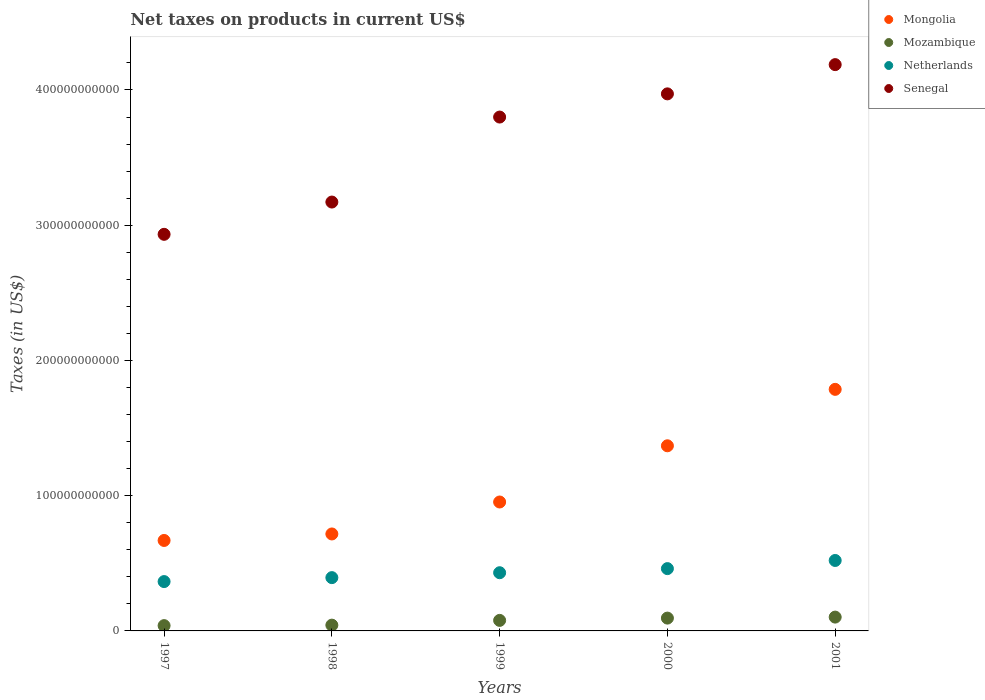Is the number of dotlines equal to the number of legend labels?
Your answer should be compact. Yes. What is the net taxes on products in Netherlands in 1997?
Offer a terse response. 3.65e+1. Across all years, what is the maximum net taxes on products in Mozambique?
Give a very brief answer. 1.02e+1. Across all years, what is the minimum net taxes on products in Senegal?
Your answer should be very brief. 2.93e+11. What is the total net taxes on products in Senegal in the graph?
Your answer should be very brief. 1.81e+12. What is the difference between the net taxes on products in Netherlands in 1998 and that in 2001?
Provide a succinct answer. -1.27e+1. What is the difference between the net taxes on products in Senegal in 2001 and the net taxes on products in Netherlands in 2000?
Offer a terse response. 3.73e+11. What is the average net taxes on products in Netherlands per year?
Make the answer very short. 4.34e+1. In the year 2000, what is the difference between the net taxes on products in Mongolia and net taxes on products in Mozambique?
Provide a short and direct response. 1.27e+11. In how many years, is the net taxes on products in Mozambique greater than 20000000000 US$?
Your response must be concise. 0. What is the ratio of the net taxes on products in Senegal in 2000 to that in 2001?
Keep it short and to the point. 0.95. Is the net taxes on products in Netherlands in 1999 less than that in 2000?
Your answer should be compact. Yes. What is the difference between the highest and the second highest net taxes on products in Mozambique?
Keep it short and to the point. 7.42e+08. What is the difference between the highest and the lowest net taxes on products in Netherlands?
Your answer should be compact. 1.56e+1. Is it the case that in every year, the sum of the net taxes on products in Netherlands and net taxes on products in Senegal  is greater than the sum of net taxes on products in Mozambique and net taxes on products in Mongolia?
Keep it short and to the point. Yes. Is it the case that in every year, the sum of the net taxes on products in Mongolia and net taxes on products in Mozambique  is greater than the net taxes on products in Netherlands?
Ensure brevity in your answer.  Yes. Is the net taxes on products in Senegal strictly greater than the net taxes on products in Netherlands over the years?
Provide a succinct answer. Yes. How many dotlines are there?
Your answer should be compact. 4. What is the difference between two consecutive major ticks on the Y-axis?
Your response must be concise. 1.00e+11. Are the values on the major ticks of Y-axis written in scientific E-notation?
Provide a short and direct response. No. Does the graph contain grids?
Provide a short and direct response. No. Where does the legend appear in the graph?
Keep it short and to the point. Top right. How many legend labels are there?
Ensure brevity in your answer.  4. How are the legend labels stacked?
Give a very brief answer. Vertical. What is the title of the graph?
Your answer should be very brief. Net taxes on products in current US$. Does "Northern Mariana Islands" appear as one of the legend labels in the graph?
Provide a succinct answer. No. What is the label or title of the X-axis?
Make the answer very short. Years. What is the label or title of the Y-axis?
Your answer should be compact. Taxes (in US$). What is the Taxes (in US$) in Mongolia in 1997?
Offer a very short reply. 6.69e+1. What is the Taxes (in US$) of Mozambique in 1997?
Your answer should be compact. 3.92e+09. What is the Taxes (in US$) of Netherlands in 1997?
Ensure brevity in your answer.  3.65e+1. What is the Taxes (in US$) in Senegal in 1997?
Make the answer very short. 2.93e+11. What is the Taxes (in US$) in Mongolia in 1998?
Your response must be concise. 7.17e+1. What is the Taxes (in US$) of Mozambique in 1998?
Your answer should be very brief. 4.27e+09. What is the Taxes (in US$) of Netherlands in 1998?
Your answer should be very brief. 3.94e+1. What is the Taxes (in US$) of Senegal in 1998?
Provide a short and direct response. 3.17e+11. What is the Taxes (in US$) of Mongolia in 1999?
Your response must be concise. 9.53e+1. What is the Taxes (in US$) in Mozambique in 1999?
Your answer should be very brief. 7.79e+09. What is the Taxes (in US$) of Netherlands in 1999?
Your answer should be compact. 4.30e+1. What is the Taxes (in US$) in Senegal in 1999?
Give a very brief answer. 3.80e+11. What is the Taxes (in US$) of Mongolia in 2000?
Make the answer very short. 1.37e+11. What is the Taxes (in US$) of Mozambique in 2000?
Your answer should be very brief. 9.48e+09. What is the Taxes (in US$) of Netherlands in 2000?
Make the answer very short. 4.61e+1. What is the Taxes (in US$) in Senegal in 2000?
Your answer should be compact. 3.97e+11. What is the Taxes (in US$) in Mongolia in 2001?
Your answer should be very brief. 1.79e+11. What is the Taxes (in US$) of Mozambique in 2001?
Keep it short and to the point. 1.02e+1. What is the Taxes (in US$) in Netherlands in 2001?
Your answer should be very brief. 5.21e+1. What is the Taxes (in US$) in Senegal in 2001?
Make the answer very short. 4.19e+11. Across all years, what is the maximum Taxes (in US$) of Mongolia?
Offer a terse response. 1.79e+11. Across all years, what is the maximum Taxes (in US$) of Mozambique?
Make the answer very short. 1.02e+1. Across all years, what is the maximum Taxes (in US$) in Netherlands?
Your response must be concise. 5.21e+1. Across all years, what is the maximum Taxes (in US$) of Senegal?
Make the answer very short. 4.19e+11. Across all years, what is the minimum Taxes (in US$) in Mongolia?
Make the answer very short. 6.69e+1. Across all years, what is the minimum Taxes (in US$) of Mozambique?
Provide a succinct answer. 3.92e+09. Across all years, what is the minimum Taxes (in US$) of Netherlands?
Ensure brevity in your answer.  3.65e+1. Across all years, what is the minimum Taxes (in US$) of Senegal?
Provide a succinct answer. 2.93e+11. What is the total Taxes (in US$) in Mongolia in the graph?
Ensure brevity in your answer.  5.49e+11. What is the total Taxes (in US$) of Mozambique in the graph?
Offer a very short reply. 3.57e+1. What is the total Taxes (in US$) of Netherlands in the graph?
Ensure brevity in your answer.  2.17e+11. What is the total Taxes (in US$) of Senegal in the graph?
Your response must be concise. 1.81e+12. What is the difference between the Taxes (in US$) in Mongolia in 1997 and that in 1998?
Provide a succinct answer. -4.81e+09. What is the difference between the Taxes (in US$) of Mozambique in 1997 and that in 1998?
Make the answer very short. -3.53e+08. What is the difference between the Taxes (in US$) of Netherlands in 1997 and that in 1998?
Give a very brief answer. -2.92e+09. What is the difference between the Taxes (in US$) in Senegal in 1997 and that in 1998?
Your answer should be compact. -2.39e+1. What is the difference between the Taxes (in US$) of Mongolia in 1997 and that in 1999?
Provide a succinct answer. -2.84e+1. What is the difference between the Taxes (in US$) of Mozambique in 1997 and that in 1999?
Offer a terse response. -3.87e+09. What is the difference between the Taxes (in US$) in Netherlands in 1997 and that in 1999?
Your answer should be compact. -6.55e+09. What is the difference between the Taxes (in US$) in Senegal in 1997 and that in 1999?
Your answer should be very brief. -8.67e+1. What is the difference between the Taxes (in US$) in Mongolia in 1997 and that in 2000?
Your answer should be very brief. -7.00e+1. What is the difference between the Taxes (in US$) in Mozambique in 1997 and that in 2000?
Offer a terse response. -5.56e+09. What is the difference between the Taxes (in US$) in Netherlands in 1997 and that in 2000?
Make the answer very short. -9.58e+09. What is the difference between the Taxes (in US$) in Senegal in 1997 and that in 2000?
Your answer should be compact. -1.04e+11. What is the difference between the Taxes (in US$) in Mongolia in 1997 and that in 2001?
Give a very brief answer. -1.12e+11. What is the difference between the Taxes (in US$) of Mozambique in 1997 and that in 2001?
Ensure brevity in your answer.  -6.30e+09. What is the difference between the Taxes (in US$) in Netherlands in 1997 and that in 2001?
Ensure brevity in your answer.  -1.56e+1. What is the difference between the Taxes (in US$) of Senegal in 1997 and that in 2001?
Your answer should be compact. -1.25e+11. What is the difference between the Taxes (in US$) in Mongolia in 1998 and that in 1999?
Give a very brief answer. -2.36e+1. What is the difference between the Taxes (in US$) of Mozambique in 1998 and that in 1999?
Your answer should be compact. -3.52e+09. What is the difference between the Taxes (in US$) of Netherlands in 1998 and that in 1999?
Give a very brief answer. -3.63e+09. What is the difference between the Taxes (in US$) of Senegal in 1998 and that in 1999?
Offer a terse response. -6.28e+1. What is the difference between the Taxes (in US$) of Mongolia in 1998 and that in 2000?
Provide a short and direct response. -6.52e+1. What is the difference between the Taxes (in US$) of Mozambique in 1998 and that in 2000?
Give a very brief answer. -5.21e+09. What is the difference between the Taxes (in US$) in Netherlands in 1998 and that in 2000?
Keep it short and to the point. -6.66e+09. What is the difference between the Taxes (in US$) in Senegal in 1998 and that in 2000?
Offer a terse response. -8.00e+1. What is the difference between the Taxes (in US$) in Mongolia in 1998 and that in 2001?
Provide a succinct answer. -1.07e+11. What is the difference between the Taxes (in US$) of Mozambique in 1998 and that in 2001?
Ensure brevity in your answer.  -5.95e+09. What is the difference between the Taxes (in US$) of Netherlands in 1998 and that in 2001?
Offer a very short reply. -1.27e+1. What is the difference between the Taxes (in US$) of Senegal in 1998 and that in 2001?
Your response must be concise. -1.02e+11. What is the difference between the Taxes (in US$) in Mongolia in 1999 and that in 2000?
Give a very brief answer. -4.16e+1. What is the difference between the Taxes (in US$) of Mozambique in 1999 and that in 2000?
Your answer should be very brief. -1.69e+09. What is the difference between the Taxes (in US$) of Netherlands in 1999 and that in 2000?
Your answer should be very brief. -3.04e+09. What is the difference between the Taxes (in US$) in Senegal in 1999 and that in 2000?
Your response must be concise. -1.72e+1. What is the difference between the Taxes (in US$) of Mongolia in 1999 and that in 2001?
Offer a very short reply. -8.33e+1. What is the difference between the Taxes (in US$) of Mozambique in 1999 and that in 2001?
Make the answer very short. -2.43e+09. What is the difference between the Taxes (in US$) of Netherlands in 1999 and that in 2001?
Offer a very short reply. -9.06e+09. What is the difference between the Taxes (in US$) in Senegal in 1999 and that in 2001?
Keep it short and to the point. -3.88e+1. What is the difference between the Taxes (in US$) in Mongolia in 2000 and that in 2001?
Keep it short and to the point. -4.17e+1. What is the difference between the Taxes (in US$) of Mozambique in 2000 and that in 2001?
Give a very brief answer. -7.42e+08. What is the difference between the Taxes (in US$) of Netherlands in 2000 and that in 2001?
Provide a short and direct response. -6.02e+09. What is the difference between the Taxes (in US$) in Senegal in 2000 and that in 2001?
Your answer should be compact. -2.16e+1. What is the difference between the Taxes (in US$) of Mongolia in 1997 and the Taxes (in US$) of Mozambique in 1998?
Your answer should be very brief. 6.26e+1. What is the difference between the Taxes (in US$) of Mongolia in 1997 and the Taxes (in US$) of Netherlands in 1998?
Your response must be concise. 2.75e+1. What is the difference between the Taxes (in US$) of Mongolia in 1997 and the Taxes (in US$) of Senegal in 1998?
Offer a terse response. -2.50e+11. What is the difference between the Taxes (in US$) of Mozambique in 1997 and the Taxes (in US$) of Netherlands in 1998?
Provide a short and direct response. -3.55e+1. What is the difference between the Taxes (in US$) in Mozambique in 1997 and the Taxes (in US$) in Senegal in 1998?
Give a very brief answer. -3.13e+11. What is the difference between the Taxes (in US$) of Netherlands in 1997 and the Taxes (in US$) of Senegal in 1998?
Your answer should be compact. -2.81e+11. What is the difference between the Taxes (in US$) in Mongolia in 1997 and the Taxes (in US$) in Mozambique in 1999?
Offer a very short reply. 5.91e+1. What is the difference between the Taxes (in US$) of Mongolia in 1997 and the Taxes (in US$) of Netherlands in 1999?
Your answer should be compact. 2.39e+1. What is the difference between the Taxes (in US$) of Mongolia in 1997 and the Taxes (in US$) of Senegal in 1999?
Make the answer very short. -3.13e+11. What is the difference between the Taxes (in US$) in Mozambique in 1997 and the Taxes (in US$) in Netherlands in 1999?
Provide a short and direct response. -3.91e+1. What is the difference between the Taxes (in US$) in Mozambique in 1997 and the Taxes (in US$) in Senegal in 1999?
Provide a short and direct response. -3.76e+11. What is the difference between the Taxes (in US$) in Netherlands in 1997 and the Taxes (in US$) in Senegal in 1999?
Ensure brevity in your answer.  -3.43e+11. What is the difference between the Taxes (in US$) in Mongolia in 1997 and the Taxes (in US$) in Mozambique in 2000?
Make the answer very short. 5.74e+1. What is the difference between the Taxes (in US$) in Mongolia in 1997 and the Taxes (in US$) in Netherlands in 2000?
Give a very brief answer. 2.08e+1. What is the difference between the Taxes (in US$) in Mongolia in 1997 and the Taxes (in US$) in Senegal in 2000?
Ensure brevity in your answer.  -3.30e+11. What is the difference between the Taxes (in US$) of Mozambique in 1997 and the Taxes (in US$) of Netherlands in 2000?
Your answer should be very brief. -4.22e+1. What is the difference between the Taxes (in US$) of Mozambique in 1997 and the Taxes (in US$) of Senegal in 2000?
Give a very brief answer. -3.93e+11. What is the difference between the Taxes (in US$) in Netherlands in 1997 and the Taxes (in US$) in Senegal in 2000?
Provide a short and direct response. -3.61e+11. What is the difference between the Taxes (in US$) of Mongolia in 1997 and the Taxes (in US$) of Mozambique in 2001?
Make the answer very short. 5.67e+1. What is the difference between the Taxes (in US$) in Mongolia in 1997 and the Taxes (in US$) in Netherlands in 2001?
Offer a very short reply. 1.48e+1. What is the difference between the Taxes (in US$) in Mongolia in 1997 and the Taxes (in US$) in Senegal in 2001?
Offer a very short reply. -3.52e+11. What is the difference between the Taxes (in US$) of Mozambique in 1997 and the Taxes (in US$) of Netherlands in 2001?
Ensure brevity in your answer.  -4.82e+1. What is the difference between the Taxes (in US$) of Mozambique in 1997 and the Taxes (in US$) of Senegal in 2001?
Keep it short and to the point. -4.15e+11. What is the difference between the Taxes (in US$) of Netherlands in 1997 and the Taxes (in US$) of Senegal in 2001?
Provide a succinct answer. -3.82e+11. What is the difference between the Taxes (in US$) of Mongolia in 1998 and the Taxes (in US$) of Mozambique in 1999?
Make the answer very short. 6.39e+1. What is the difference between the Taxes (in US$) of Mongolia in 1998 and the Taxes (in US$) of Netherlands in 1999?
Offer a terse response. 2.87e+1. What is the difference between the Taxes (in US$) in Mongolia in 1998 and the Taxes (in US$) in Senegal in 1999?
Ensure brevity in your answer.  -3.08e+11. What is the difference between the Taxes (in US$) in Mozambique in 1998 and the Taxes (in US$) in Netherlands in 1999?
Provide a succinct answer. -3.88e+1. What is the difference between the Taxes (in US$) in Mozambique in 1998 and the Taxes (in US$) in Senegal in 1999?
Give a very brief answer. -3.76e+11. What is the difference between the Taxes (in US$) in Netherlands in 1998 and the Taxes (in US$) in Senegal in 1999?
Offer a very short reply. -3.41e+11. What is the difference between the Taxes (in US$) of Mongolia in 1998 and the Taxes (in US$) of Mozambique in 2000?
Give a very brief answer. 6.22e+1. What is the difference between the Taxes (in US$) of Mongolia in 1998 and the Taxes (in US$) of Netherlands in 2000?
Provide a short and direct response. 2.56e+1. What is the difference between the Taxes (in US$) in Mongolia in 1998 and the Taxes (in US$) in Senegal in 2000?
Your response must be concise. -3.25e+11. What is the difference between the Taxes (in US$) in Mozambique in 1998 and the Taxes (in US$) in Netherlands in 2000?
Your answer should be compact. -4.18e+1. What is the difference between the Taxes (in US$) of Mozambique in 1998 and the Taxes (in US$) of Senegal in 2000?
Give a very brief answer. -3.93e+11. What is the difference between the Taxes (in US$) of Netherlands in 1998 and the Taxes (in US$) of Senegal in 2000?
Give a very brief answer. -3.58e+11. What is the difference between the Taxes (in US$) in Mongolia in 1998 and the Taxes (in US$) in Mozambique in 2001?
Make the answer very short. 6.15e+1. What is the difference between the Taxes (in US$) of Mongolia in 1998 and the Taxes (in US$) of Netherlands in 2001?
Make the answer very short. 1.96e+1. What is the difference between the Taxes (in US$) of Mongolia in 1998 and the Taxes (in US$) of Senegal in 2001?
Offer a terse response. -3.47e+11. What is the difference between the Taxes (in US$) in Mozambique in 1998 and the Taxes (in US$) in Netherlands in 2001?
Offer a terse response. -4.78e+1. What is the difference between the Taxes (in US$) in Mozambique in 1998 and the Taxes (in US$) in Senegal in 2001?
Offer a very short reply. -4.14e+11. What is the difference between the Taxes (in US$) in Netherlands in 1998 and the Taxes (in US$) in Senegal in 2001?
Your response must be concise. -3.79e+11. What is the difference between the Taxes (in US$) of Mongolia in 1999 and the Taxes (in US$) of Mozambique in 2000?
Make the answer very short. 8.59e+1. What is the difference between the Taxes (in US$) of Mongolia in 1999 and the Taxes (in US$) of Netherlands in 2000?
Offer a terse response. 4.93e+1. What is the difference between the Taxes (in US$) of Mongolia in 1999 and the Taxes (in US$) of Senegal in 2000?
Provide a succinct answer. -3.02e+11. What is the difference between the Taxes (in US$) in Mozambique in 1999 and the Taxes (in US$) in Netherlands in 2000?
Make the answer very short. -3.83e+1. What is the difference between the Taxes (in US$) in Mozambique in 1999 and the Taxes (in US$) in Senegal in 2000?
Offer a terse response. -3.89e+11. What is the difference between the Taxes (in US$) in Netherlands in 1999 and the Taxes (in US$) in Senegal in 2000?
Offer a terse response. -3.54e+11. What is the difference between the Taxes (in US$) of Mongolia in 1999 and the Taxes (in US$) of Mozambique in 2001?
Ensure brevity in your answer.  8.51e+1. What is the difference between the Taxes (in US$) in Mongolia in 1999 and the Taxes (in US$) in Netherlands in 2001?
Keep it short and to the point. 4.32e+1. What is the difference between the Taxes (in US$) of Mongolia in 1999 and the Taxes (in US$) of Senegal in 2001?
Keep it short and to the point. -3.23e+11. What is the difference between the Taxes (in US$) of Mozambique in 1999 and the Taxes (in US$) of Netherlands in 2001?
Give a very brief answer. -4.43e+1. What is the difference between the Taxes (in US$) of Mozambique in 1999 and the Taxes (in US$) of Senegal in 2001?
Offer a very short reply. -4.11e+11. What is the difference between the Taxes (in US$) in Netherlands in 1999 and the Taxes (in US$) in Senegal in 2001?
Offer a very short reply. -3.76e+11. What is the difference between the Taxes (in US$) in Mongolia in 2000 and the Taxes (in US$) in Mozambique in 2001?
Offer a very short reply. 1.27e+11. What is the difference between the Taxes (in US$) of Mongolia in 2000 and the Taxes (in US$) of Netherlands in 2001?
Your answer should be compact. 8.48e+1. What is the difference between the Taxes (in US$) in Mongolia in 2000 and the Taxes (in US$) in Senegal in 2001?
Offer a terse response. -2.82e+11. What is the difference between the Taxes (in US$) in Mozambique in 2000 and the Taxes (in US$) in Netherlands in 2001?
Provide a succinct answer. -4.26e+1. What is the difference between the Taxes (in US$) of Mozambique in 2000 and the Taxes (in US$) of Senegal in 2001?
Your response must be concise. -4.09e+11. What is the difference between the Taxes (in US$) in Netherlands in 2000 and the Taxes (in US$) in Senegal in 2001?
Provide a succinct answer. -3.73e+11. What is the average Taxes (in US$) in Mongolia per year?
Give a very brief answer. 1.10e+11. What is the average Taxes (in US$) in Mozambique per year?
Offer a very short reply. 7.13e+09. What is the average Taxes (in US$) in Netherlands per year?
Your answer should be compact. 4.34e+1. What is the average Taxes (in US$) in Senegal per year?
Offer a terse response. 3.61e+11. In the year 1997, what is the difference between the Taxes (in US$) in Mongolia and Taxes (in US$) in Mozambique?
Your response must be concise. 6.30e+1. In the year 1997, what is the difference between the Taxes (in US$) of Mongolia and Taxes (in US$) of Netherlands?
Provide a short and direct response. 3.04e+1. In the year 1997, what is the difference between the Taxes (in US$) in Mongolia and Taxes (in US$) in Senegal?
Ensure brevity in your answer.  -2.26e+11. In the year 1997, what is the difference between the Taxes (in US$) in Mozambique and Taxes (in US$) in Netherlands?
Keep it short and to the point. -3.26e+1. In the year 1997, what is the difference between the Taxes (in US$) of Mozambique and Taxes (in US$) of Senegal?
Your response must be concise. -2.89e+11. In the year 1997, what is the difference between the Taxes (in US$) of Netherlands and Taxes (in US$) of Senegal?
Your answer should be very brief. -2.57e+11. In the year 1998, what is the difference between the Taxes (in US$) in Mongolia and Taxes (in US$) in Mozambique?
Provide a succinct answer. 6.74e+1. In the year 1998, what is the difference between the Taxes (in US$) in Mongolia and Taxes (in US$) in Netherlands?
Your answer should be very brief. 3.23e+1. In the year 1998, what is the difference between the Taxes (in US$) of Mongolia and Taxes (in US$) of Senegal?
Your response must be concise. -2.45e+11. In the year 1998, what is the difference between the Taxes (in US$) of Mozambique and Taxes (in US$) of Netherlands?
Keep it short and to the point. -3.51e+1. In the year 1998, what is the difference between the Taxes (in US$) in Mozambique and Taxes (in US$) in Senegal?
Give a very brief answer. -3.13e+11. In the year 1998, what is the difference between the Taxes (in US$) in Netherlands and Taxes (in US$) in Senegal?
Your response must be concise. -2.78e+11. In the year 1999, what is the difference between the Taxes (in US$) in Mongolia and Taxes (in US$) in Mozambique?
Provide a short and direct response. 8.75e+1. In the year 1999, what is the difference between the Taxes (in US$) of Mongolia and Taxes (in US$) of Netherlands?
Keep it short and to the point. 5.23e+1. In the year 1999, what is the difference between the Taxes (in US$) in Mongolia and Taxes (in US$) in Senegal?
Give a very brief answer. -2.85e+11. In the year 1999, what is the difference between the Taxes (in US$) of Mozambique and Taxes (in US$) of Netherlands?
Ensure brevity in your answer.  -3.52e+1. In the year 1999, what is the difference between the Taxes (in US$) in Mozambique and Taxes (in US$) in Senegal?
Offer a very short reply. -3.72e+11. In the year 1999, what is the difference between the Taxes (in US$) in Netherlands and Taxes (in US$) in Senegal?
Provide a succinct answer. -3.37e+11. In the year 2000, what is the difference between the Taxes (in US$) of Mongolia and Taxes (in US$) of Mozambique?
Offer a very short reply. 1.27e+11. In the year 2000, what is the difference between the Taxes (in US$) of Mongolia and Taxes (in US$) of Netherlands?
Offer a very short reply. 9.08e+1. In the year 2000, what is the difference between the Taxes (in US$) in Mongolia and Taxes (in US$) in Senegal?
Provide a succinct answer. -2.60e+11. In the year 2000, what is the difference between the Taxes (in US$) in Mozambique and Taxes (in US$) in Netherlands?
Make the answer very short. -3.66e+1. In the year 2000, what is the difference between the Taxes (in US$) of Mozambique and Taxes (in US$) of Senegal?
Keep it short and to the point. -3.88e+11. In the year 2000, what is the difference between the Taxes (in US$) of Netherlands and Taxes (in US$) of Senegal?
Your answer should be very brief. -3.51e+11. In the year 2001, what is the difference between the Taxes (in US$) in Mongolia and Taxes (in US$) in Mozambique?
Ensure brevity in your answer.  1.68e+11. In the year 2001, what is the difference between the Taxes (in US$) of Mongolia and Taxes (in US$) of Netherlands?
Your answer should be compact. 1.27e+11. In the year 2001, what is the difference between the Taxes (in US$) in Mongolia and Taxes (in US$) in Senegal?
Offer a very short reply. -2.40e+11. In the year 2001, what is the difference between the Taxes (in US$) of Mozambique and Taxes (in US$) of Netherlands?
Your response must be concise. -4.19e+1. In the year 2001, what is the difference between the Taxes (in US$) in Mozambique and Taxes (in US$) in Senegal?
Your answer should be very brief. -4.09e+11. In the year 2001, what is the difference between the Taxes (in US$) in Netherlands and Taxes (in US$) in Senegal?
Ensure brevity in your answer.  -3.67e+11. What is the ratio of the Taxes (in US$) of Mongolia in 1997 to that in 1998?
Make the answer very short. 0.93. What is the ratio of the Taxes (in US$) of Mozambique in 1997 to that in 1998?
Your response must be concise. 0.92. What is the ratio of the Taxes (in US$) of Netherlands in 1997 to that in 1998?
Provide a succinct answer. 0.93. What is the ratio of the Taxes (in US$) of Senegal in 1997 to that in 1998?
Give a very brief answer. 0.92. What is the ratio of the Taxes (in US$) in Mongolia in 1997 to that in 1999?
Your answer should be compact. 0.7. What is the ratio of the Taxes (in US$) of Mozambique in 1997 to that in 1999?
Keep it short and to the point. 0.5. What is the ratio of the Taxes (in US$) in Netherlands in 1997 to that in 1999?
Keep it short and to the point. 0.85. What is the ratio of the Taxes (in US$) in Senegal in 1997 to that in 1999?
Provide a short and direct response. 0.77. What is the ratio of the Taxes (in US$) in Mongolia in 1997 to that in 2000?
Your answer should be very brief. 0.49. What is the ratio of the Taxes (in US$) in Mozambique in 1997 to that in 2000?
Your response must be concise. 0.41. What is the ratio of the Taxes (in US$) of Netherlands in 1997 to that in 2000?
Ensure brevity in your answer.  0.79. What is the ratio of the Taxes (in US$) of Senegal in 1997 to that in 2000?
Provide a short and direct response. 0.74. What is the ratio of the Taxes (in US$) of Mongolia in 1997 to that in 2001?
Give a very brief answer. 0.37. What is the ratio of the Taxes (in US$) in Mozambique in 1997 to that in 2001?
Keep it short and to the point. 0.38. What is the ratio of the Taxes (in US$) of Netherlands in 1997 to that in 2001?
Offer a very short reply. 0.7. What is the ratio of the Taxes (in US$) in Senegal in 1997 to that in 2001?
Offer a terse response. 0.7. What is the ratio of the Taxes (in US$) of Mongolia in 1998 to that in 1999?
Your answer should be very brief. 0.75. What is the ratio of the Taxes (in US$) of Mozambique in 1998 to that in 1999?
Keep it short and to the point. 0.55. What is the ratio of the Taxes (in US$) in Netherlands in 1998 to that in 1999?
Offer a terse response. 0.92. What is the ratio of the Taxes (in US$) of Senegal in 1998 to that in 1999?
Your answer should be compact. 0.83. What is the ratio of the Taxes (in US$) in Mongolia in 1998 to that in 2000?
Your answer should be compact. 0.52. What is the ratio of the Taxes (in US$) of Mozambique in 1998 to that in 2000?
Offer a terse response. 0.45. What is the ratio of the Taxes (in US$) in Netherlands in 1998 to that in 2000?
Your response must be concise. 0.86. What is the ratio of the Taxes (in US$) of Senegal in 1998 to that in 2000?
Offer a terse response. 0.8. What is the ratio of the Taxes (in US$) in Mongolia in 1998 to that in 2001?
Your response must be concise. 0.4. What is the ratio of the Taxes (in US$) in Mozambique in 1998 to that in 2001?
Provide a short and direct response. 0.42. What is the ratio of the Taxes (in US$) in Netherlands in 1998 to that in 2001?
Ensure brevity in your answer.  0.76. What is the ratio of the Taxes (in US$) of Senegal in 1998 to that in 2001?
Provide a succinct answer. 0.76. What is the ratio of the Taxes (in US$) of Mongolia in 1999 to that in 2000?
Keep it short and to the point. 0.7. What is the ratio of the Taxes (in US$) of Mozambique in 1999 to that in 2000?
Make the answer very short. 0.82. What is the ratio of the Taxes (in US$) in Netherlands in 1999 to that in 2000?
Offer a terse response. 0.93. What is the ratio of the Taxes (in US$) of Senegal in 1999 to that in 2000?
Ensure brevity in your answer.  0.96. What is the ratio of the Taxes (in US$) in Mongolia in 1999 to that in 2001?
Your answer should be compact. 0.53. What is the ratio of the Taxes (in US$) in Mozambique in 1999 to that in 2001?
Give a very brief answer. 0.76. What is the ratio of the Taxes (in US$) in Netherlands in 1999 to that in 2001?
Make the answer very short. 0.83. What is the ratio of the Taxes (in US$) of Senegal in 1999 to that in 2001?
Offer a terse response. 0.91. What is the ratio of the Taxes (in US$) of Mongolia in 2000 to that in 2001?
Your answer should be compact. 0.77. What is the ratio of the Taxes (in US$) in Mozambique in 2000 to that in 2001?
Make the answer very short. 0.93. What is the ratio of the Taxes (in US$) of Netherlands in 2000 to that in 2001?
Your answer should be very brief. 0.88. What is the ratio of the Taxes (in US$) of Senegal in 2000 to that in 2001?
Keep it short and to the point. 0.95. What is the difference between the highest and the second highest Taxes (in US$) of Mongolia?
Your response must be concise. 4.17e+1. What is the difference between the highest and the second highest Taxes (in US$) of Mozambique?
Provide a short and direct response. 7.42e+08. What is the difference between the highest and the second highest Taxes (in US$) in Netherlands?
Your answer should be very brief. 6.02e+09. What is the difference between the highest and the second highest Taxes (in US$) of Senegal?
Your answer should be very brief. 2.16e+1. What is the difference between the highest and the lowest Taxes (in US$) of Mongolia?
Offer a terse response. 1.12e+11. What is the difference between the highest and the lowest Taxes (in US$) in Mozambique?
Give a very brief answer. 6.30e+09. What is the difference between the highest and the lowest Taxes (in US$) of Netherlands?
Provide a succinct answer. 1.56e+1. What is the difference between the highest and the lowest Taxes (in US$) of Senegal?
Your response must be concise. 1.25e+11. 